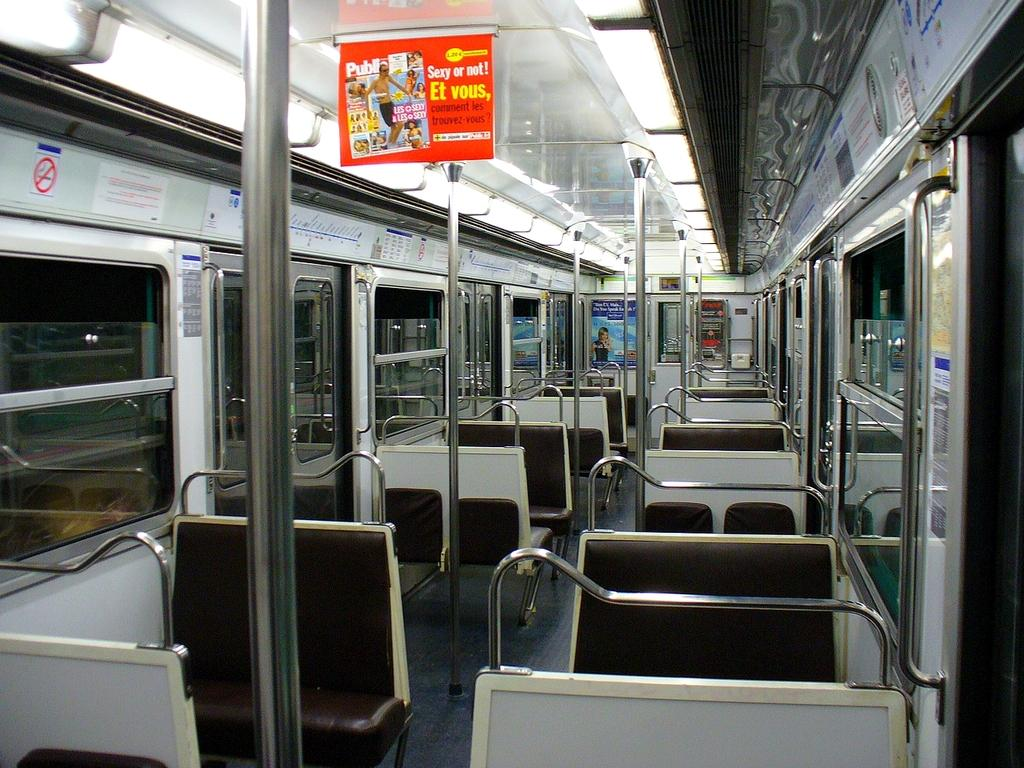<image>
Provide a brief description of the given image. Bus with a sign on top that says "Sexy or not!". 